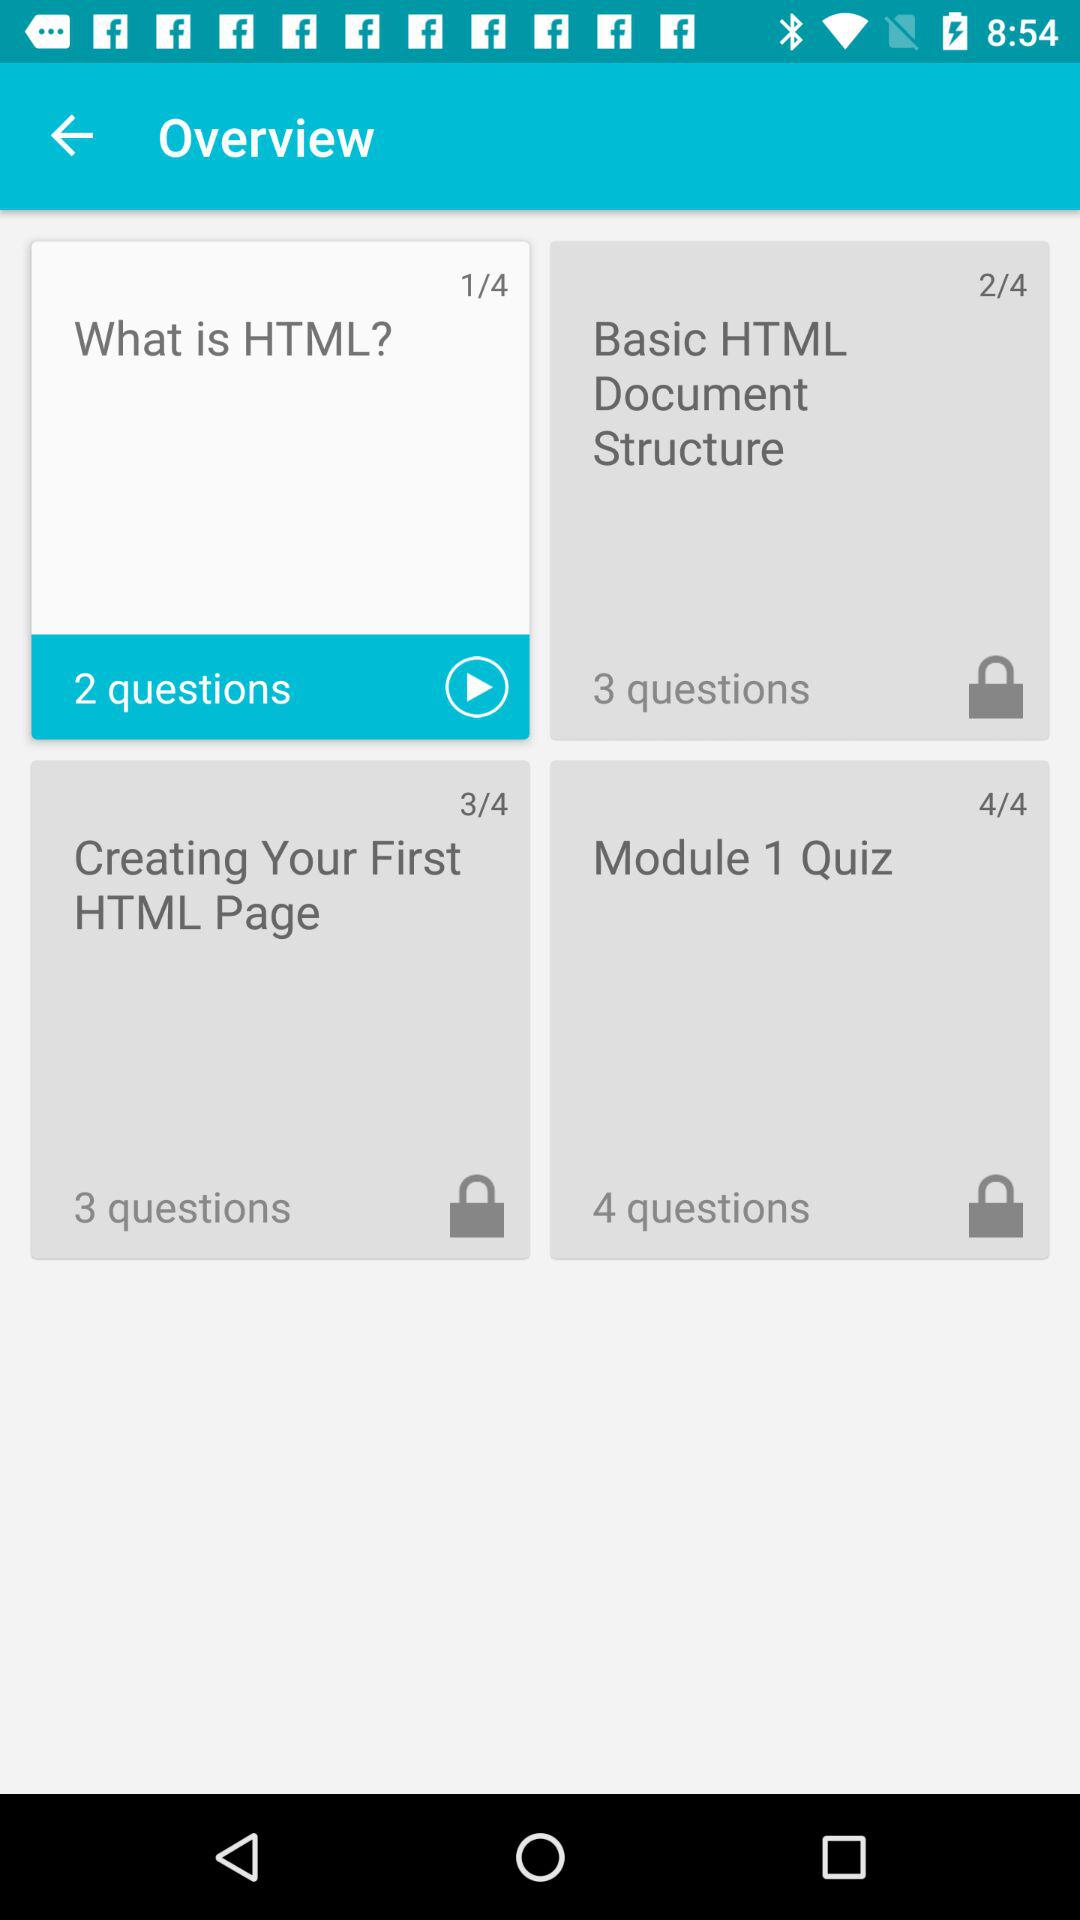How many questions are in the section with the most questions?
Answer the question using a single word or phrase. 4 